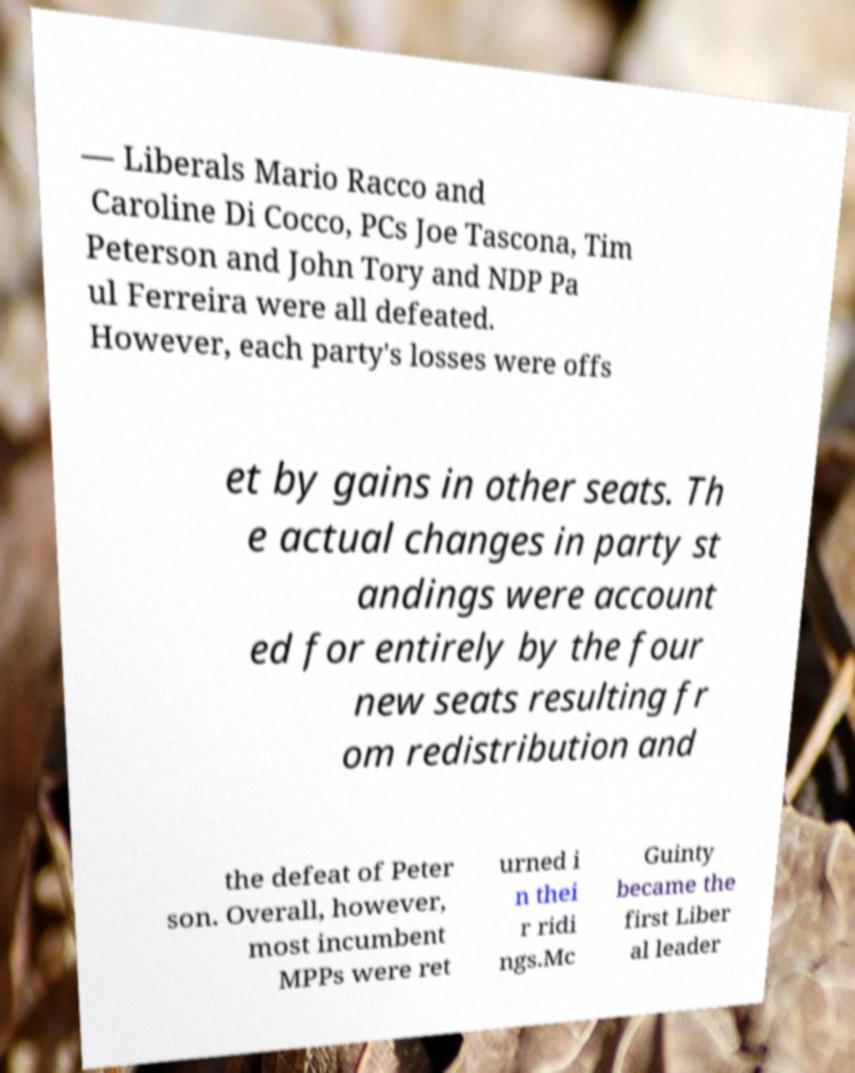What messages or text are displayed in this image? I need them in a readable, typed format. — Liberals Mario Racco and Caroline Di Cocco, PCs Joe Tascona, Tim Peterson and John Tory and NDP Pa ul Ferreira were all defeated. However, each party's losses were offs et by gains in other seats. Th e actual changes in party st andings were account ed for entirely by the four new seats resulting fr om redistribution and the defeat of Peter son. Overall, however, most incumbent MPPs were ret urned i n thei r ridi ngs.Mc Guinty became the first Liber al leader 